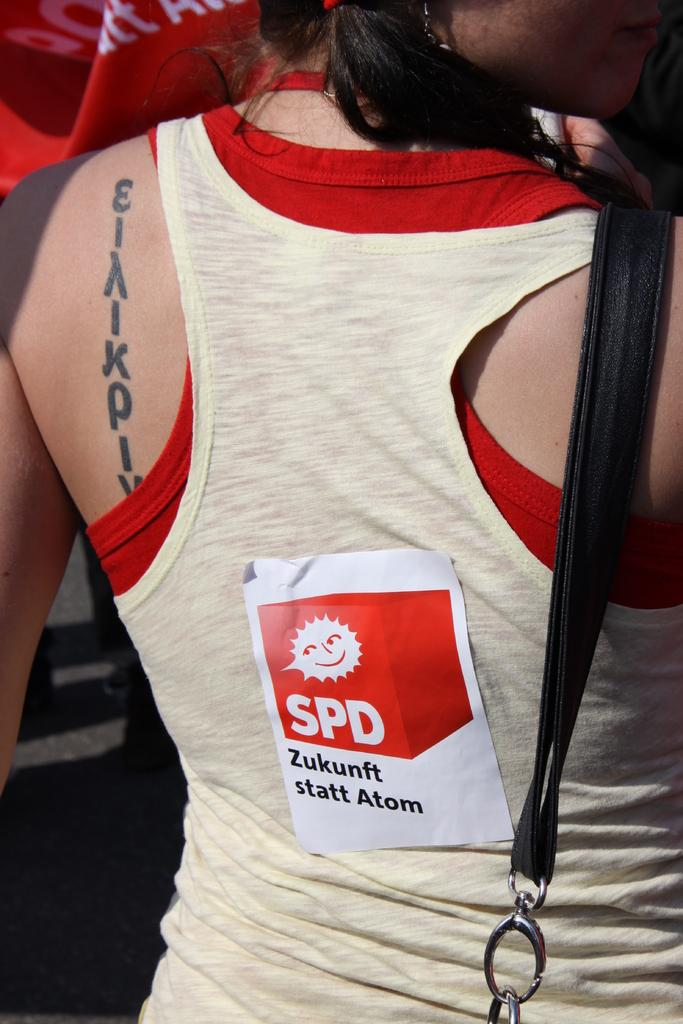<image>
Summarize the visual content of the image. A woman with a red and white tank top has a sticker that reads "SPD statt Atom". 